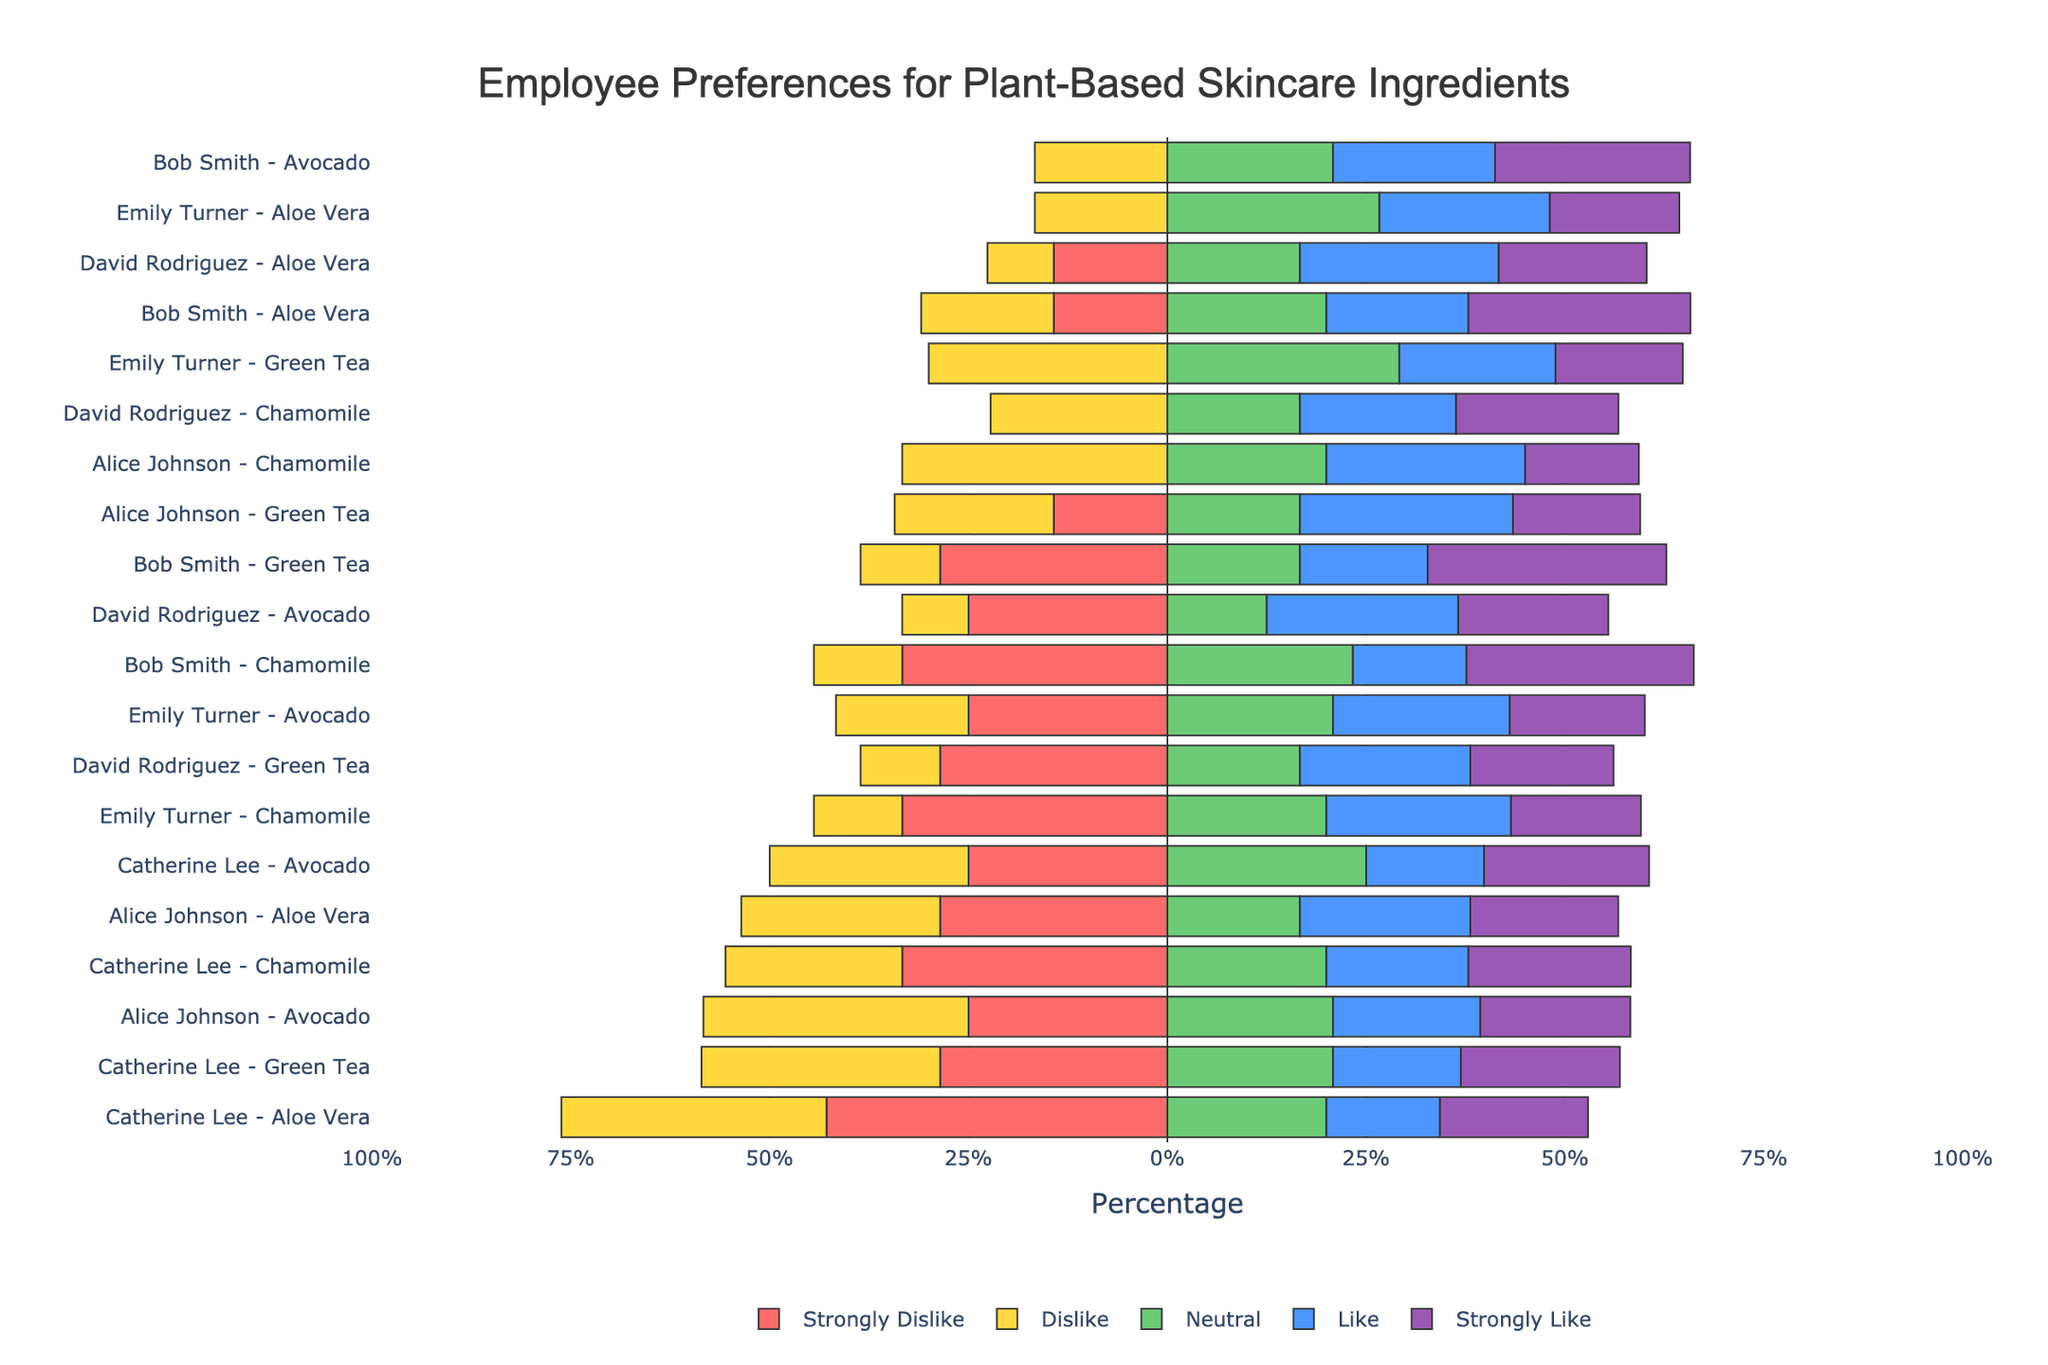Which ingredient has the highest "Strongly Like" percentage for Alice Johnson? Examine the bar for "Strongly Like" for each ingredient associated with Alice Johnson. Avocado shows the highest percentage in this category.
Answer: Avocado Which ingredient has the lowest "Dislike" percentage for Bob Smith? Observe the "Dislike" bars for Bob Smith's ingredients. Chamomile and Green Tea both show the lowest with similar percentages.
Answer: Chamomile and Green Tea Which employee has the strongest preference for Green Tea compared to other ingredients? By comparing the "Strongly Like" bars, Bob Smith shows the highest percentage for Green Tea.
Answer: Bob Smith For which ingredient does Catherine Lee have the highest "Neutral" sentiment? Check the "Neutral" bars for each ingredient for Catherine Lee, noticing that Aloe Vera has the highest percentage.
Answer: Aloe Vera How does David Rodriguez's "Like" sentiment for Aloe Vera compare with the same sentiment for Avocado? Calculate the "Like" percentage for both Aloe Vera and Avocado. Aloe Vera has a lower percentage in the "Like" category compared to Avocado.
Answer: Lower Who exhibits more "Strongly Dislike" sentiments for Avocado, Catherine Lee or Emily Turner? Compare the "Strongly Dislike" bars for Catherine Lee and Emily Turner. Catherine Lee shows a higher percentage.
Answer: Catherine Lee What's the average "Strongly Like" percentage across all employees for Chamomile? Add the "Strongly Like" percentages of all employees for Chamomile (7 + 14 + 10 + 10 + 8) and divide by 5. The sum is 49, and the average is 49 / 5 = 9.8.
Answer: 9.8 Which employee has the most balanced sentiment distribution for Green Tea? Evaluate the balance by checking the lengths of bars in each sentiment category. Emily Turner's sentiment distribution for Green Tea appears the most balanced across different categories.
Answer: Emily Turner Is Aloe Vera more liked or disliked by the majority of the employees? Sum the percentages of "Like" and "Strongly Like" categories and compare with the sum of "Dislike" and "Strongly Dislike" categories. In all cases, the "Like" and "Strongly Like" percentages are higher.
Answer: More liked 